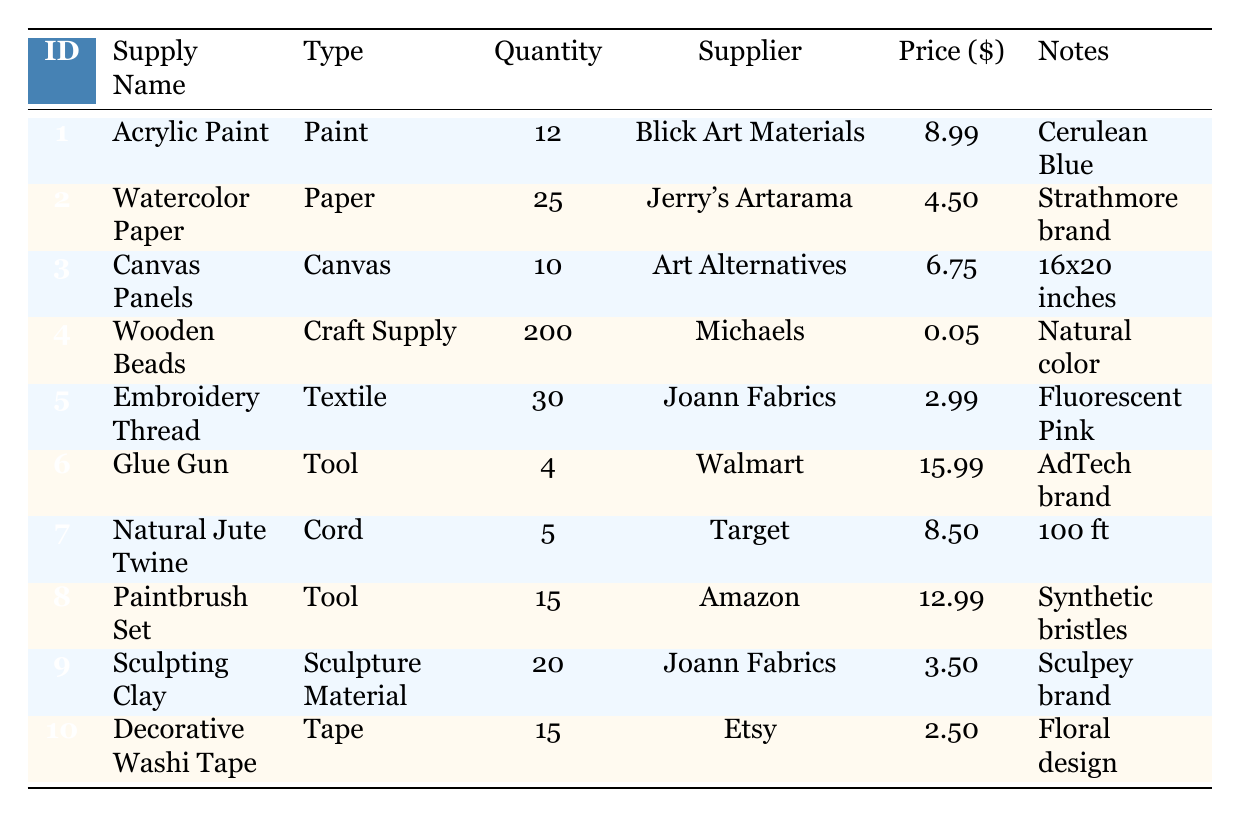What is the total quantity of supplies available for "Paint"? In the table, there are two items under the type "Paint": Acrylic Paint (12) and Watercolor Paper (25). Therefore, the total quantity is 12 + 25 = 37.
Answer: 37 Which supplier provides "Wooden Beads"? The table shows that the item "Wooden Beads" is supplied by Michaels.
Answer: Michaels Is "Natural Jute Twine" available in a size other than 100 ft? The table indicates that "Natural Jute Twine" is listed with a size of 100 ft and no alternative sizes are provided for this item. Thus, the answer is false.
Answer: No What is the average price of all craft supplies in the table? First, sum up the prices of all items: (8.99 + 4.50 + 6.75 + 0.05 + 2.99 + 15.99 + 8.50 + 12.99 + 3.50 + 2.50) = 63.76. There are 10 items, so the average price is 63.76 / 10 = 6.376.
Answer: 6.38 How many items are available in the "Tool" category? The table includes two items categorized as "Tool": Glue Gun (4) and Paintbrush Set (15). Thus, the total number of items in the "Tool" category is 2.
Answer: 2 Is there more than one supplier for the "Sculpting Clay"? The table lists "Sculpting Clay," supplied by Joann Fabrics, with no other suppliers mentioned for this item, making the statement false.
Answer: No What is the total quantity of "Acrylic Paint" and "Canvas Panels"? The quantity of "Acrylic Paint" is 12 and that of "Canvas Panels" is 10. Summing these gives us 12 + 10 = 22.
Answer: 22 How many different types of craft supplies are listed in the table? By analyzing the "Type" column, we see the following types: Paint, Paper, Canvas, Craft Supply, Textile, Tool, Cord, and Sculpture Material, totaling 8 different types.
Answer: 8 What is the price of the most expensive item? The table displays the prices, with the highest price found for the Glue Gun, at 15.99.
Answer: 15.99 